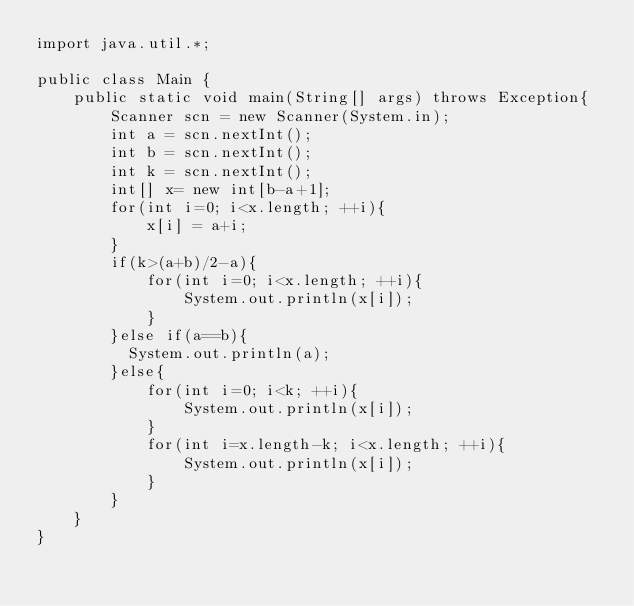Convert code to text. <code><loc_0><loc_0><loc_500><loc_500><_Java_>import java.util.*;

public class Main {
	public static void main(String[] args) throws Exception{
		Scanner scn = new Scanner(System.in);
		int a = scn.nextInt();
		int b = scn.nextInt();
      	int k = scn.nextInt();
      	int[] x= new int[b-a+1];
      	for(int i=0; i<x.length; ++i){
			x[i] = a+i;
		}
      	if(k>(a+b)/2-a){
        	for(int i=0; i<x.length; ++i){
				System.out.println(x[i]);
			}
        }else if(a==b){
          System.out.println(a);
        }else{
         	for(int i=0; i<k; ++i){
				System.out.println(x[i]);
			}
          	for(int i=x.length-k; i<x.length; ++i){
				System.out.println(x[i]);
			}
        }
	}
}
</code> 